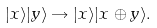<formula> <loc_0><loc_0><loc_500><loc_500>| x \rangle | y \rangle \rightarrow | x \rangle | x \oplus y \rangle .</formula> 